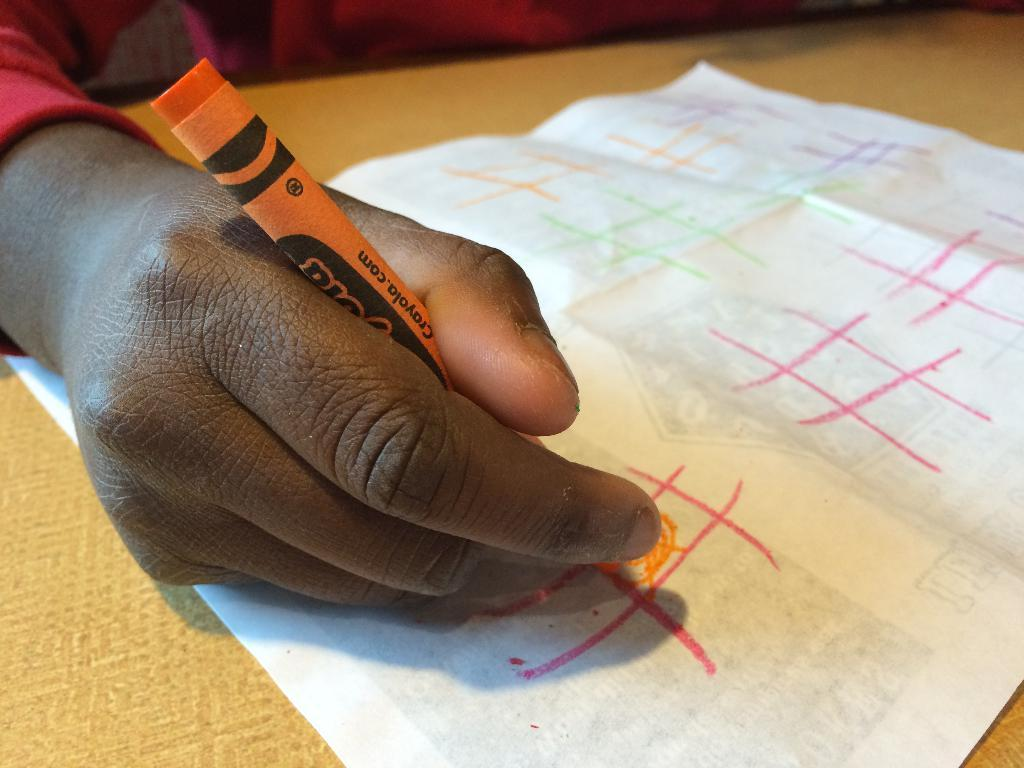Who is present in the image? There is a person in the image. What is the person holding in the image? The person is holding a crayon. What is the person doing with the crayon? The person is drawing something. What is in front of the person? There is a table in front of the person. What is on the table? There is a paper on the table. What type of pot is visible on the table in the image? There is no pot visible on the table in the image. Can you see a plane flying in the background of the image? There is no plane visible in the image. 